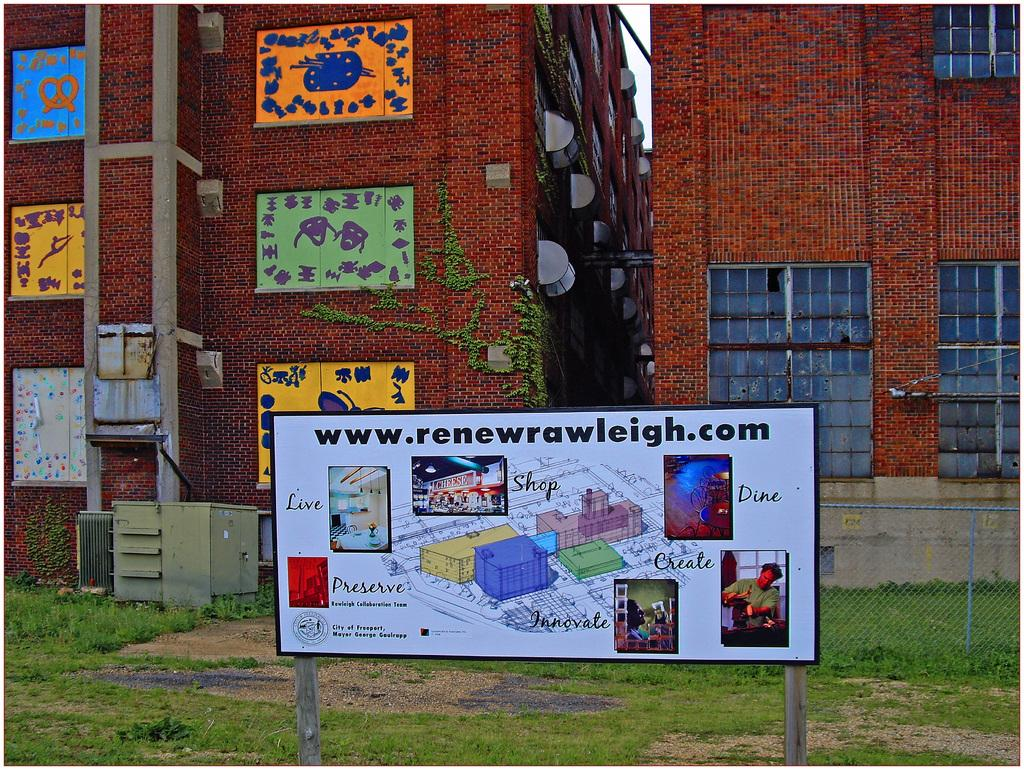<image>
Present a compact description of the photo's key features. An advertisement for www.renewrawleigh.com is out side of a red brick building. 